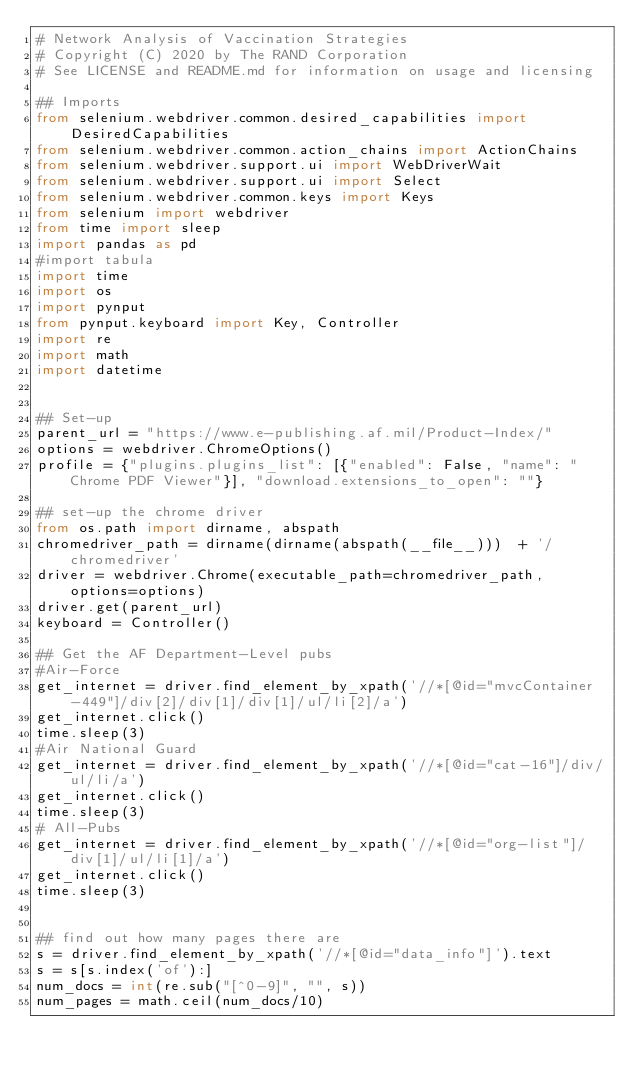Convert code to text. <code><loc_0><loc_0><loc_500><loc_500><_Python_># Network Analysis of Vaccination Strategies
# Copyright (C) 2020 by The RAND Corporation
# See LICENSE and README.md for information on usage and licensing

## Imports
from selenium.webdriver.common.desired_capabilities import DesiredCapabilities
from selenium.webdriver.common.action_chains import ActionChains
from selenium.webdriver.support.ui import WebDriverWait
from selenium.webdriver.support.ui import Select
from selenium.webdriver.common.keys import Keys
from selenium import webdriver
from time import sleep
import pandas as pd
#import tabula
import time
import os
import pynput
from pynput.keyboard import Key, Controller
import re
import math
import datetime


## Set-up
parent_url = "https://www.e-publishing.af.mil/Product-Index/"
options = webdriver.ChromeOptions()
profile = {"plugins.plugins_list": [{"enabled": False, "name": "Chrome PDF Viewer"}], "download.extensions_to_open": ""}

## set-up the chrome driver
from os.path import dirname, abspath
chromedriver_path = dirname(dirname(abspath(__file__)))  + '/chromedriver'
driver = webdriver.Chrome(executable_path=chromedriver_path, options=options)
driver.get(parent_url)
keyboard = Controller()

## Get the AF Department-Level pubs
#Air-Force
get_internet = driver.find_element_by_xpath('//*[@id="mvcContainer-449"]/div[2]/div[1]/div[1]/ul/li[2]/a')
get_internet.click()
time.sleep(3)
#Air National Guard
get_internet = driver.find_element_by_xpath('//*[@id="cat-16"]/div/ul/li/a')
get_internet.click()
time.sleep(3)
# All-Pubs
get_internet = driver.find_element_by_xpath('//*[@id="org-list"]/div[1]/ul/li[1]/a')
get_internet.click()
time.sleep(3)


## find out how many pages there are
s = driver.find_element_by_xpath('//*[@id="data_info"]').text
s = s[s.index('of'):]
num_docs = int(re.sub("[^0-9]", "", s))
num_pages = math.ceil(num_docs/10)

</code> 